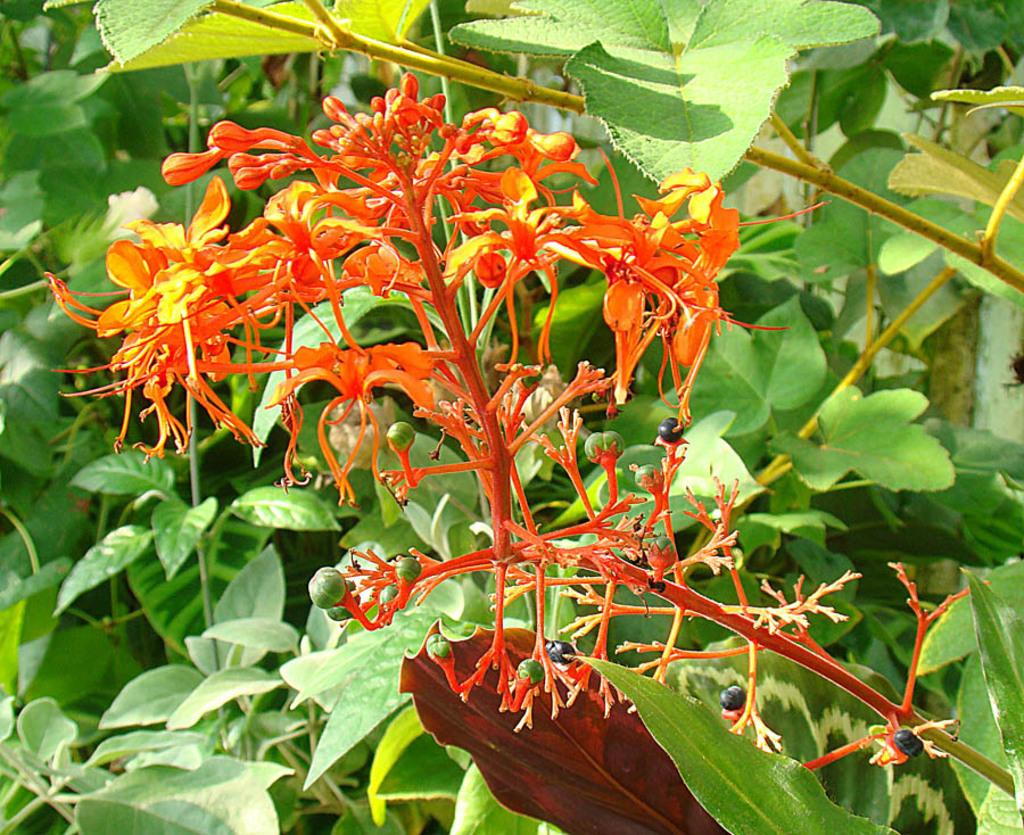What type of living organisms can be seen in the image? Flowers, buds, and plants can be seen in the image. Can you describe the stage of growth for the flowers in the image? The image shows both flowers and buds, indicating that some are fully bloomed while others are still in the process of opening. What is the primary subject of the image? The primary subject of the image is the flowers and plants. What type of dock can be seen in the image? There is no dock present in the image; it features flowers, buds, and plants. What type of crook is visible in the image? There is no crook present in the image; it features flowers, buds, and plants. 